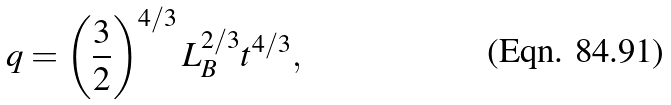<formula> <loc_0><loc_0><loc_500><loc_500>q = \left ( \frac { 3 } { 2 } \right ) ^ { 4 / 3 } L ^ { 2 / 3 } _ { B } t ^ { 4 / 3 } ,</formula> 